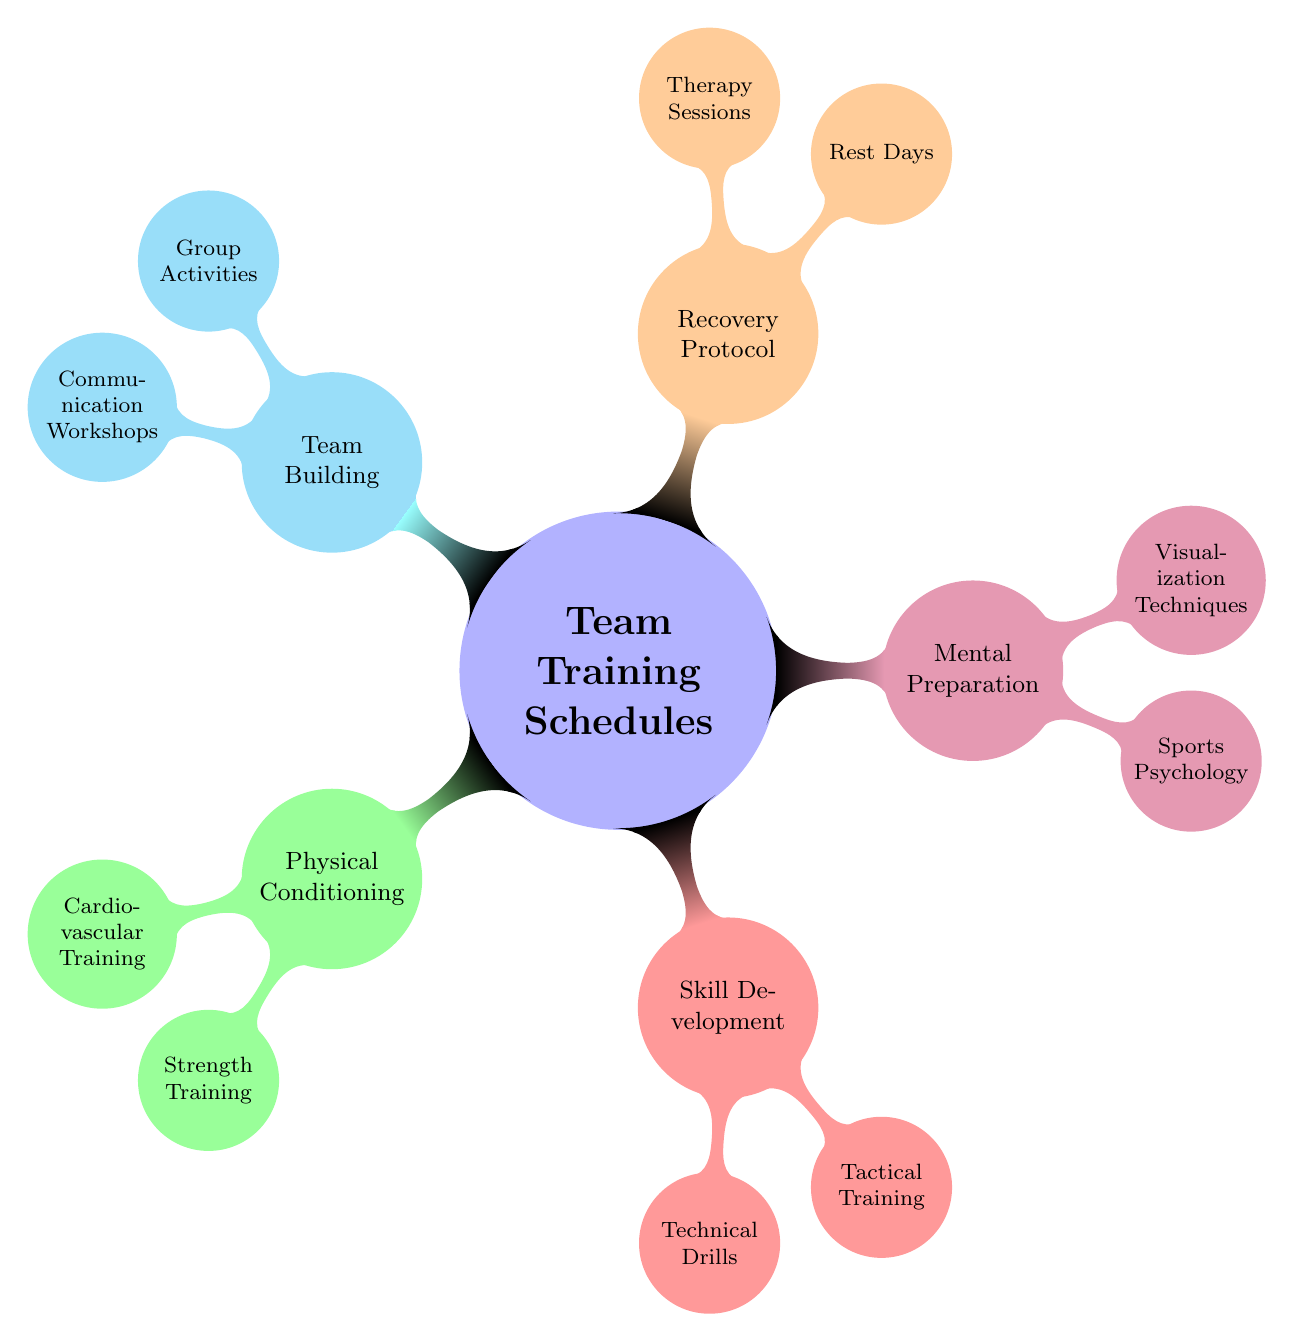What's the main topic of the mind map? The central node of the mind map indicates the main focus, which is "Team Training Schedules for Peak Performance."
Answer: Team Training Schedules for Peak Performance How many main categories are there in the diagram? The diagram contains five main categories branching out from the central node. These are Physical Conditioning, Skill Development, Mental Preparation, Recovery Protocol, and Team Building.
Answer: 5 What is one type of activity listed under Recovery Protocol? The Recovery Protocol category includes two types of activities: Rest Days and Therapy Sessions. Either one could be a valid answer, but one specific activity is "Rest Days."
Answer: Rest Days Which two types of training fall under Physical Conditioning? In the Physical Conditioning category, there are two specific types of training: Cardiovascular Training and Strength Training. Both are sub-nodes directly connected to Physical Conditioning.
Answer: Cardiovascular Training and Strength Training What is one activity mentioned under Mental Preparation? Under the Mental Preparation category, there are two activities detailed: Sports Psychology and Visualization Techniques. One specific activity is "Sports Psychology."
Answer: Sports Psychology Which category includes "Conflict Resolution Training"? The "Conflict Resolution Training" is specifically listed under the Communication Workshops sub-node. This node falls under the Team Building category.
Answer: Team Building What is the relationship between Skill Development and Tactical Training? Tactical Training is a sub-node within the Skill Development category, indicating that it is part of the broader skill development focus for peak performance.
Answer: Tactical Training is a sub-node of Skill Development How many activities are listed under Team Building? Team Building is detailed with two specific activities: Group Activities and Communication Workshops. Therefore, there are two listed activities under this category.
Answer: 2 Which category has activities aimed specifically at mental skills? The Mental Preparation category is focused on enhancing mental skills, featuring activities like Sports Psychology and Visualization Techniques.
Answer: Mental Preparation 